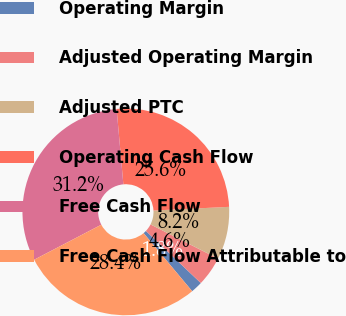Convert chart. <chart><loc_0><loc_0><loc_500><loc_500><pie_chart><fcel>Operating Margin<fcel>Adjusted Operating Margin<fcel>Adjusted PTC<fcel>Operating Cash Flow<fcel>Free Cash Flow<fcel>Free Cash Flow Attributable to<nl><fcel>1.83%<fcel>4.62%<fcel>8.24%<fcel>25.64%<fcel>31.23%<fcel>28.43%<nl></chart> 